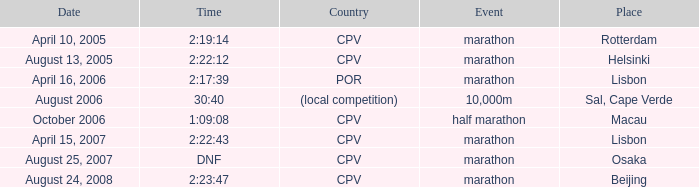What is the Place of the Event on August 25, 2007? Osaka. 